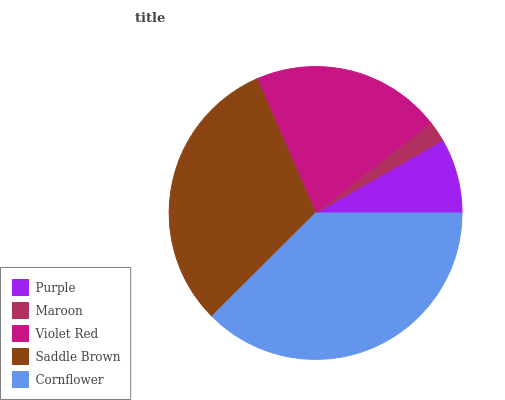Is Maroon the minimum?
Answer yes or no. Yes. Is Cornflower the maximum?
Answer yes or no. Yes. Is Violet Red the minimum?
Answer yes or no. No. Is Violet Red the maximum?
Answer yes or no. No. Is Violet Red greater than Maroon?
Answer yes or no. Yes. Is Maroon less than Violet Red?
Answer yes or no. Yes. Is Maroon greater than Violet Red?
Answer yes or no. No. Is Violet Red less than Maroon?
Answer yes or no. No. Is Violet Red the high median?
Answer yes or no. Yes. Is Violet Red the low median?
Answer yes or no. Yes. Is Maroon the high median?
Answer yes or no. No. Is Purple the low median?
Answer yes or no. No. 